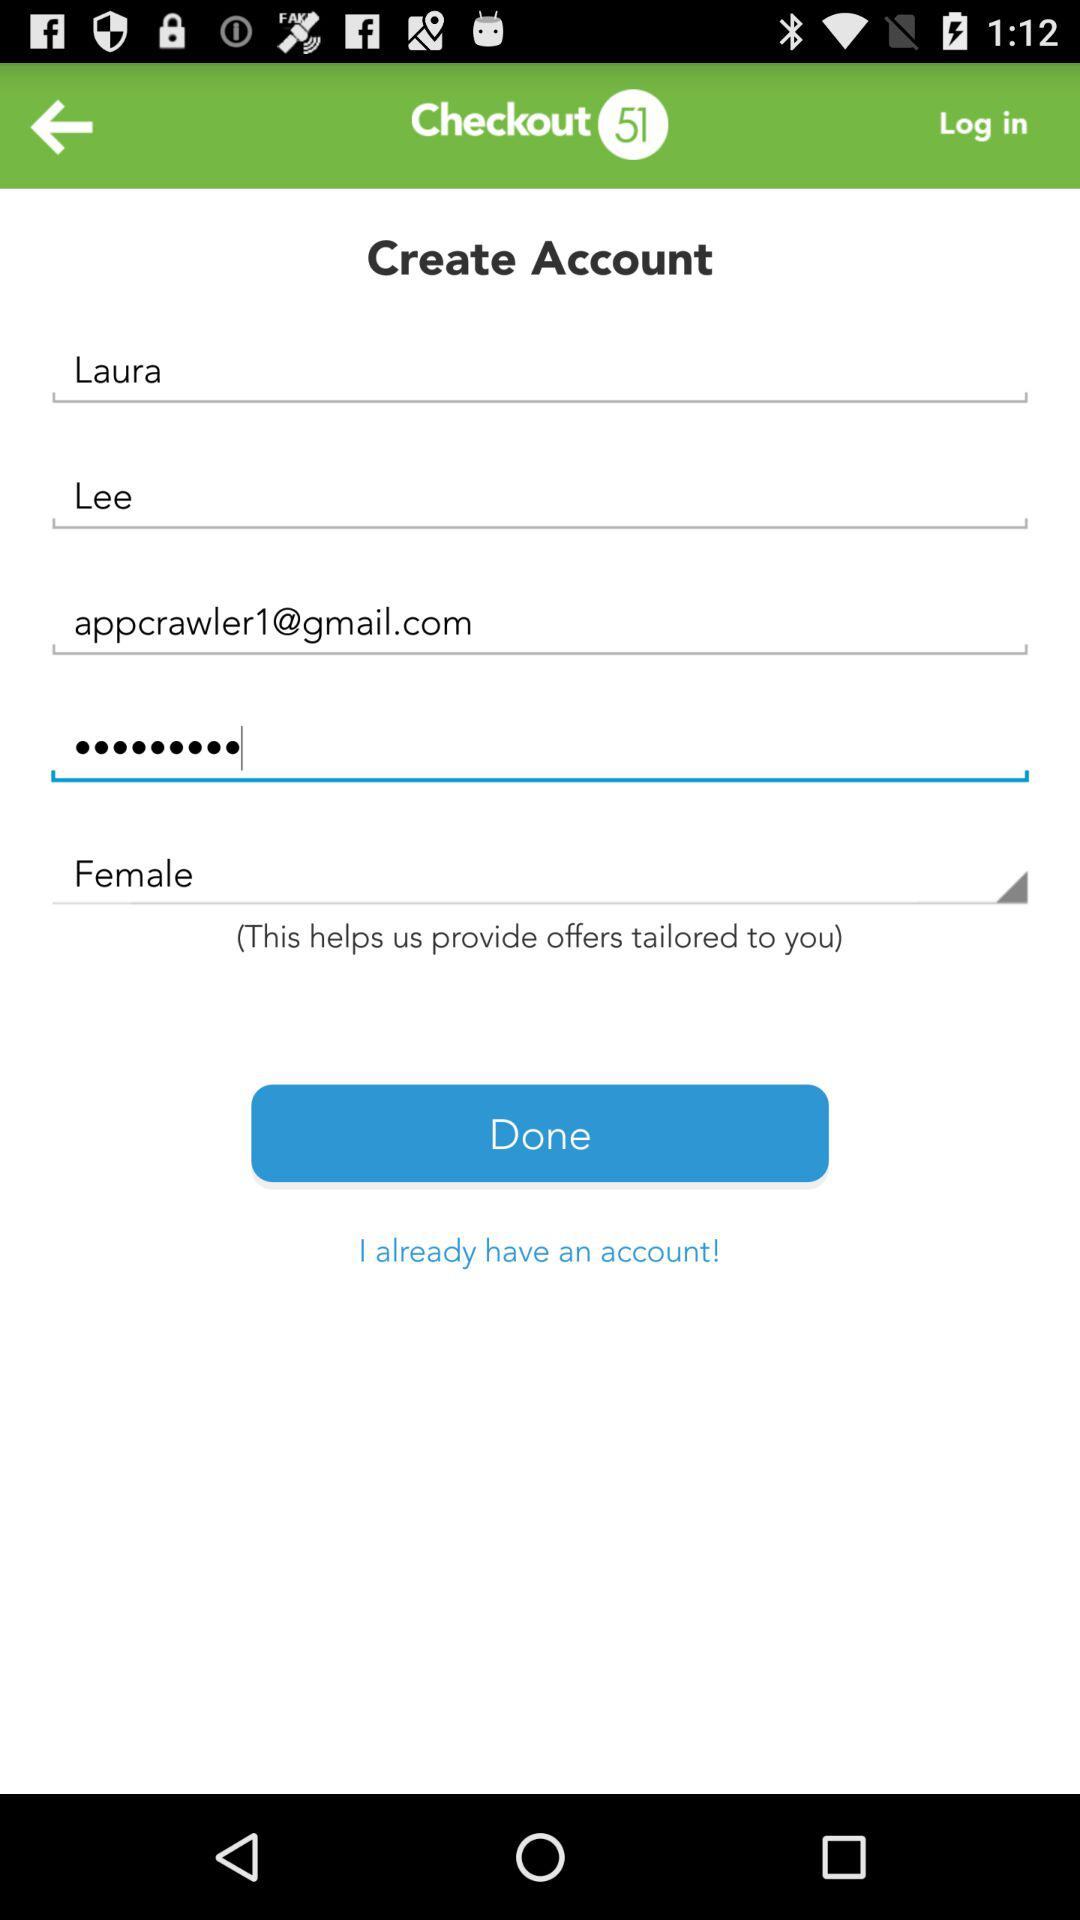How many textboxes are there in the form?
Answer the question using a single word or phrase. 5 